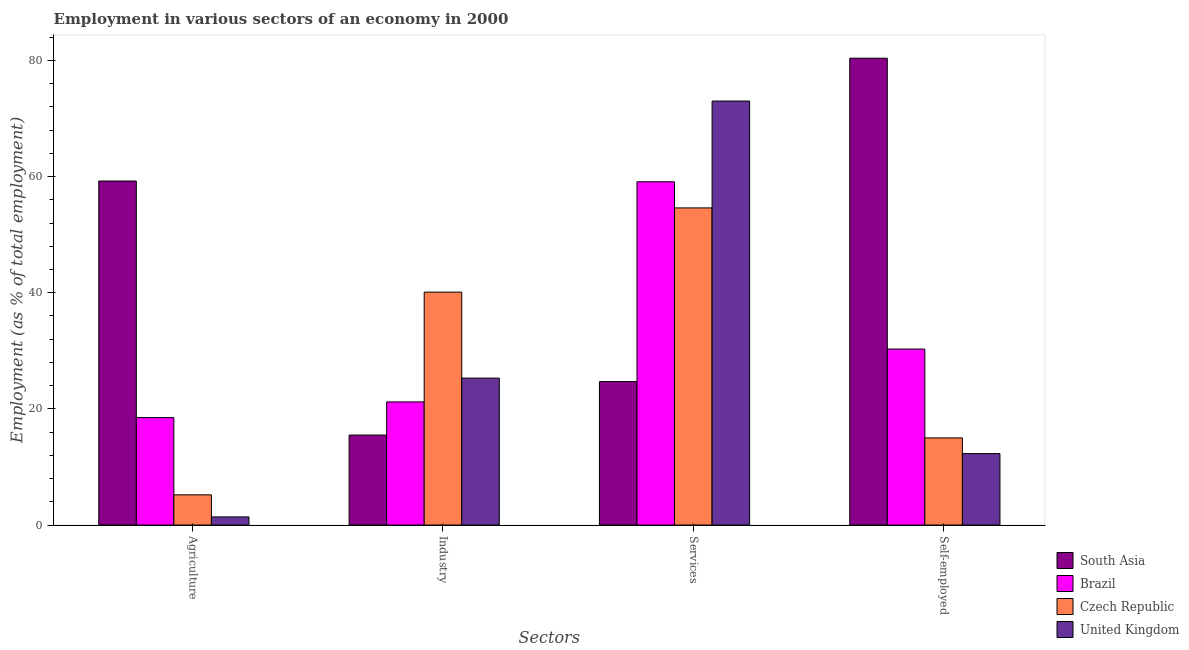How many different coloured bars are there?
Give a very brief answer. 4. Are the number of bars on each tick of the X-axis equal?
Keep it short and to the point. Yes. How many bars are there on the 3rd tick from the right?
Make the answer very short. 4. What is the label of the 1st group of bars from the left?
Give a very brief answer. Agriculture. What is the percentage of self employed workers in South Asia?
Provide a short and direct response. 80.37. Across all countries, what is the maximum percentage of self employed workers?
Give a very brief answer. 80.37. Across all countries, what is the minimum percentage of self employed workers?
Provide a succinct answer. 12.3. What is the total percentage of self employed workers in the graph?
Offer a very short reply. 137.97. What is the difference between the percentage of workers in agriculture in South Asia and that in Brazil?
Your answer should be very brief. 40.73. What is the difference between the percentage of self employed workers in Czech Republic and the percentage of workers in services in South Asia?
Provide a short and direct response. -9.7. What is the average percentage of workers in services per country?
Make the answer very short. 52.85. What is the difference between the percentage of workers in industry and percentage of workers in agriculture in United Kingdom?
Ensure brevity in your answer.  23.9. What is the ratio of the percentage of self employed workers in Czech Republic to that in Brazil?
Your answer should be very brief. 0.5. Is the percentage of self employed workers in Czech Republic less than that in Brazil?
Ensure brevity in your answer.  Yes. What is the difference between the highest and the second highest percentage of self employed workers?
Give a very brief answer. 50.07. What is the difference between the highest and the lowest percentage of workers in services?
Make the answer very short. 48.3. In how many countries, is the percentage of workers in industry greater than the average percentage of workers in industry taken over all countries?
Your answer should be compact. 1. Is the sum of the percentage of workers in industry in Brazil and Czech Republic greater than the maximum percentage of workers in agriculture across all countries?
Provide a succinct answer. Yes. What does the 1st bar from the left in Self-employed represents?
Make the answer very short. South Asia. What does the 4th bar from the right in Self-employed represents?
Ensure brevity in your answer.  South Asia. Is it the case that in every country, the sum of the percentage of workers in agriculture and percentage of workers in industry is greater than the percentage of workers in services?
Make the answer very short. No. How many bars are there?
Your response must be concise. 16. How many countries are there in the graph?
Offer a terse response. 4. What is the difference between two consecutive major ticks on the Y-axis?
Your answer should be very brief. 20. Does the graph contain any zero values?
Provide a short and direct response. No. Where does the legend appear in the graph?
Give a very brief answer. Bottom right. What is the title of the graph?
Offer a very short reply. Employment in various sectors of an economy in 2000. Does "Latin America(all income levels)" appear as one of the legend labels in the graph?
Offer a very short reply. No. What is the label or title of the X-axis?
Your response must be concise. Sectors. What is the label or title of the Y-axis?
Provide a succinct answer. Employment (as % of total employment). What is the Employment (as % of total employment) of South Asia in Agriculture?
Your answer should be very brief. 59.23. What is the Employment (as % of total employment) of Brazil in Agriculture?
Ensure brevity in your answer.  18.5. What is the Employment (as % of total employment) of Czech Republic in Agriculture?
Offer a terse response. 5.2. What is the Employment (as % of total employment) in United Kingdom in Agriculture?
Offer a very short reply. 1.4. What is the Employment (as % of total employment) in South Asia in Industry?
Make the answer very short. 15.49. What is the Employment (as % of total employment) of Brazil in Industry?
Keep it short and to the point. 21.2. What is the Employment (as % of total employment) in Czech Republic in Industry?
Your response must be concise. 40.1. What is the Employment (as % of total employment) in United Kingdom in Industry?
Offer a very short reply. 25.3. What is the Employment (as % of total employment) of South Asia in Services?
Your response must be concise. 24.7. What is the Employment (as % of total employment) in Brazil in Services?
Give a very brief answer. 59.1. What is the Employment (as % of total employment) of Czech Republic in Services?
Your response must be concise. 54.6. What is the Employment (as % of total employment) in United Kingdom in Services?
Provide a short and direct response. 73. What is the Employment (as % of total employment) in South Asia in Self-employed?
Your answer should be compact. 80.37. What is the Employment (as % of total employment) in Brazil in Self-employed?
Make the answer very short. 30.3. What is the Employment (as % of total employment) in United Kingdom in Self-employed?
Provide a short and direct response. 12.3. Across all Sectors, what is the maximum Employment (as % of total employment) of South Asia?
Your response must be concise. 80.37. Across all Sectors, what is the maximum Employment (as % of total employment) in Brazil?
Make the answer very short. 59.1. Across all Sectors, what is the maximum Employment (as % of total employment) of Czech Republic?
Your answer should be very brief. 54.6. Across all Sectors, what is the minimum Employment (as % of total employment) in South Asia?
Your answer should be very brief. 15.49. Across all Sectors, what is the minimum Employment (as % of total employment) of Czech Republic?
Give a very brief answer. 5.2. Across all Sectors, what is the minimum Employment (as % of total employment) in United Kingdom?
Make the answer very short. 1.4. What is the total Employment (as % of total employment) of South Asia in the graph?
Make the answer very short. 179.8. What is the total Employment (as % of total employment) in Brazil in the graph?
Your response must be concise. 129.1. What is the total Employment (as % of total employment) of Czech Republic in the graph?
Your answer should be compact. 114.9. What is the total Employment (as % of total employment) in United Kingdom in the graph?
Offer a very short reply. 112. What is the difference between the Employment (as % of total employment) in South Asia in Agriculture and that in Industry?
Offer a terse response. 43.74. What is the difference between the Employment (as % of total employment) in Brazil in Agriculture and that in Industry?
Your answer should be very brief. -2.7. What is the difference between the Employment (as % of total employment) in Czech Republic in Agriculture and that in Industry?
Provide a succinct answer. -34.9. What is the difference between the Employment (as % of total employment) of United Kingdom in Agriculture and that in Industry?
Provide a succinct answer. -23.9. What is the difference between the Employment (as % of total employment) in South Asia in Agriculture and that in Services?
Ensure brevity in your answer.  34.53. What is the difference between the Employment (as % of total employment) in Brazil in Agriculture and that in Services?
Make the answer very short. -40.6. What is the difference between the Employment (as % of total employment) in Czech Republic in Agriculture and that in Services?
Offer a very short reply. -49.4. What is the difference between the Employment (as % of total employment) in United Kingdom in Agriculture and that in Services?
Provide a short and direct response. -71.6. What is the difference between the Employment (as % of total employment) in South Asia in Agriculture and that in Self-employed?
Offer a very short reply. -21.14. What is the difference between the Employment (as % of total employment) in Brazil in Agriculture and that in Self-employed?
Provide a short and direct response. -11.8. What is the difference between the Employment (as % of total employment) of Czech Republic in Agriculture and that in Self-employed?
Ensure brevity in your answer.  -9.8. What is the difference between the Employment (as % of total employment) in United Kingdom in Agriculture and that in Self-employed?
Keep it short and to the point. -10.9. What is the difference between the Employment (as % of total employment) in South Asia in Industry and that in Services?
Provide a short and direct response. -9.21. What is the difference between the Employment (as % of total employment) of Brazil in Industry and that in Services?
Give a very brief answer. -37.9. What is the difference between the Employment (as % of total employment) of Czech Republic in Industry and that in Services?
Give a very brief answer. -14.5. What is the difference between the Employment (as % of total employment) in United Kingdom in Industry and that in Services?
Make the answer very short. -47.7. What is the difference between the Employment (as % of total employment) in South Asia in Industry and that in Self-employed?
Ensure brevity in your answer.  -64.88. What is the difference between the Employment (as % of total employment) of Brazil in Industry and that in Self-employed?
Offer a very short reply. -9.1. What is the difference between the Employment (as % of total employment) in Czech Republic in Industry and that in Self-employed?
Provide a succinct answer. 25.1. What is the difference between the Employment (as % of total employment) of United Kingdom in Industry and that in Self-employed?
Provide a succinct answer. 13. What is the difference between the Employment (as % of total employment) in South Asia in Services and that in Self-employed?
Keep it short and to the point. -55.67. What is the difference between the Employment (as % of total employment) of Brazil in Services and that in Self-employed?
Provide a short and direct response. 28.8. What is the difference between the Employment (as % of total employment) in Czech Republic in Services and that in Self-employed?
Provide a succinct answer. 39.6. What is the difference between the Employment (as % of total employment) of United Kingdom in Services and that in Self-employed?
Your response must be concise. 60.7. What is the difference between the Employment (as % of total employment) of South Asia in Agriculture and the Employment (as % of total employment) of Brazil in Industry?
Keep it short and to the point. 38.03. What is the difference between the Employment (as % of total employment) in South Asia in Agriculture and the Employment (as % of total employment) in Czech Republic in Industry?
Your answer should be very brief. 19.13. What is the difference between the Employment (as % of total employment) of South Asia in Agriculture and the Employment (as % of total employment) of United Kingdom in Industry?
Give a very brief answer. 33.93. What is the difference between the Employment (as % of total employment) of Brazil in Agriculture and the Employment (as % of total employment) of Czech Republic in Industry?
Ensure brevity in your answer.  -21.6. What is the difference between the Employment (as % of total employment) of Brazil in Agriculture and the Employment (as % of total employment) of United Kingdom in Industry?
Offer a terse response. -6.8. What is the difference between the Employment (as % of total employment) in Czech Republic in Agriculture and the Employment (as % of total employment) in United Kingdom in Industry?
Offer a very short reply. -20.1. What is the difference between the Employment (as % of total employment) of South Asia in Agriculture and the Employment (as % of total employment) of Brazil in Services?
Your answer should be very brief. 0.13. What is the difference between the Employment (as % of total employment) in South Asia in Agriculture and the Employment (as % of total employment) in Czech Republic in Services?
Your response must be concise. 4.63. What is the difference between the Employment (as % of total employment) of South Asia in Agriculture and the Employment (as % of total employment) of United Kingdom in Services?
Provide a short and direct response. -13.77. What is the difference between the Employment (as % of total employment) in Brazil in Agriculture and the Employment (as % of total employment) in Czech Republic in Services?
Your answer should be compact. -36.1. What is the difference between the Employment (as % of total employment) of Brazil in Agriculture and the Employment (as % of total employment) of United Kingdom in Services?
Ensure brevity in your answer.  -54.5. What is the difference between the Employment (as % of total employment) of Czech Republic in Agriculture and the Employment (as % of total employment) of United Kingdom in Services?
Ensure brevity in your answer.  -67.8. What is the difference between the Employment (as % of total employment) in South Asia in Agriculture and the Employment (as % of total employment) in Brazil in Self-employed?
Provide a short and direct response. 28.93. What is the difference between the Employment (as % of total employment) in South Asia in Agriculture and the Employment (as % of total employment) in Czech Republic in Self-employed?
Ensure brevity in your answer.  44.23. What is the difference between the Employment (as % of total employment) of South Asia in Agriculture and the Employment (as % of total employment) of United Kingdom in Self-employed?
Offer a terse response. 46.93. What is the difference between the Employment (as % of total employment) in Brazil in Agriculture and the Employment (as % of total employment) in Czech Republic in Self-employed?
Provide a short and direct response. 3.5. What is the difference between the Employment (as % of total employment) of Brazil in Agriculture and the Employment (as % of total employment) of United Kingdom in Self-employed?
Your answer should be compact. 6.2. What is the difference between the Employment (as % of total employment) of Czech Republic in Agriculture and the Employment (as % of total employment) of United Kingdom in Self-employed?
Make the answer very short. -7.1. What is the difference between the Employment (as % of total employment) of South Asia in Industry and the Employment (as % of total employment) of Brazil in Services?
Keep it short and to the point. -43.61. What is the difference between the Employment (as % of total employment) in South Asia in Industry and the Employment (as % of total employment) in Czech Republic in Services?
Ensure brevity in your answer.  -39.11. What is the difference between the Employment (as % of total employment) of South Asia in Industry and the Employment (as % of total employment) of United Kingdom in Services?
Offer a terse response. -57.51. What is the difference between the Employment (as % of total employment) of Brazil in Industry and the Employment (as % of total employment) of Czech Republic in Services?
Give a very brief answer. -33.4. What is the difference between the Employment (as % of total employment) of Brazil in Industry and the Employment (as % of total employment) of United Kingdom in Services?
Your response must be concise. -51.8. What is the difference between the Employment (as % of total employment) of Czech Republic in Industry and the Employment (as % of total employment) of United Kingdom in Services?
Your answer should be very brief. -32.9. What is the difference between the Employment (as % of total employment) of South Asia in Industry and the Employment (as % of total employment) of Brazil in Self-employed?
Make the answer very short. -14.81. What is the difference between the Employment (as % of total employment) of South Asia in Industry and the Employment (as % of total employment) of Czech Republic in Self-employed?
Keep it short and to the point. 0.49. What is the difference between the Employment (as % of total employment) of South Asia in Industry and the Employment (as % of total employment) of United Kingdom in Self-employed?
Keep it short and to the point. 3.19. What is the difference between the Employment (as % of total employment) in Czech Republic in Industry and the Employment (as % of total employment) in United Kingdom in Self-employed?
Offer a terse response. 27.8. What is the difference between the Employment (as % of total employment) of South Asia in Services and the Employment (as % of total employment) of Brazil in Self-employed?
Provide a short and direct response. -5.6. What is the difference between the Employment (as % of total employment) in South Asia in Services and the Employment (as % of total employment) in Czech Republic in Self-employed?
Your answer should be compact. 9.7. What is the difference between the Employment (as % of total employment) of South Asia in Services and the Employment (as % of total employment) of United Kingdom in Self-employed?
Your response must be concise. 12.4. What is the difference between the Employment (as % of total employment) in Brazil in Services and the Employment (as % of total employment) in Czech Republic in Self-employed?
Offer a terse response. 44.1. What is the difference between the Employment (as % of total employment) of Brazil in Services and the Employment (as % of total employment) of United Kingdom in Self-employed?
Your response must be concise. 46.8. What is the difference between the Employment (as % of total employment) of Czech Republic in Services and the Employment (as % of total employment) of United Kingdom in Self-employed?
Provide a succinct answer. 42.3. What is the average Employment (as % of total employment) of South Asia per Sectors?
Make the answer very short. 44.95. What is the average Employment (as % of total employment) in Brazil per Sectors?
Ensure brevity in your answer.  32.27. What is the average Employment (as % of total employment) in Czech Republic per Sectors?
Your answer should be very brief. 28.73. What is the average Employment (as % of total employment) in United Kingdom per Sectors?
Provide a succinct answer. 28. What is the difference between the Employment (as % of total employment) in South Asia and Employment (as % of total employment) in Brazil in Agriculture?
Offer a terse response. 40.73. What is the difference between the Employment (as % of total employment) of South Asia and Employment (as % of total employment) of Czech Republic in Agriculture?
Provide a succinct answer. 54.03. What is the difference between the Employment (as % of total employment) in South Asia and Employment (as % of total employment) in United Kingdom in Agriculture?
Provide a short and direct response. 57.83. What is the difference between the Employment (as % of total employment) of Brazil and Employment (as % of total employment) of Czech Republic in Agriculture?
Ensure brevity in your answer.  13.3. What is the difference between the Employment (as % of total employment) of Brazil and Employment (as % of total employment) of United Kingdom in Agriculture?
Give a very brief answer. 17.1. What is the difference between the Employment (as % of total employment) of Czech Republic and Employment (as % of total employment) of United Kingdom in Agriculture?
Provide a short and direct response. 3.8. What is the difference between the Employment (as % of total employment) in South Asia and Employment (as % of total employment) in Brazil in Industry?
Your response must be concise. -5.71. What is the difference between the Employment (as % of total employment) in South Asia and Employment (as % of total employment) in Czech Republic in Industry?
Ensure brevity in your answer.  -24.61. What is the difference between the Employment (as % of total employment) in South Asia and Employment (as % of total employment) in United Kingdom in Industry?
Make the answer very short. -9.81. What is the difference between the Employment (as % of total employment) of Brazil and Employment (as % of total employment) of Czech Republic in Industry?
Your answer should be compact. -18.9. What is the difference between the Employment (as % of total employment) in Czech Republic and Employment (as % of total employment) in United Kingdom in Industry?
Your answer should be compact. 14.8. What is the difference between the Employment (as % of total employment) of South Asia and Employment (as % of total employment) of Brazil in Services?
Offer a very short reply. -34.4. What is the difference between the Employment (as % of total employment) in South Asia and Employment (as % of total employment) in Czech Republic in Services?
Make the answer very short. -29.9. What is the difference between the Employment (as % of total employment) in South Asia and Employment (as % of total employment) in United Kingdom in Services?
Offer a terse response. -48.3. What is the difference between the Employment (as % of total employment) of Brazil and Employment (as % of total employment) of United Kingdom in Services?
Your answer should be compact. -13.9. What is the difference between the Employment (as % of total employment) of Czech Republic and Employment (as % of total employment) of United Kingdom in Services?
Your answer should be very brief. -18.4. What is the difference between the Employment (as % of total employment) of South Asia and Employment (as % of total employment) of Brazil in Self-employed?
Provide a succinct answer. 50.07. What is the difference between the Employment (as % of total employment) in South Asia and Employment (as % of total employment) in Czech Republic in Self-employed?
Provide a succinct answer. 65.37. What is the difference between the Employment (as % of total employment) in South Asia and Employment (as % of total employment) in United Kingdom in Self-employed?
Give a very brief answer. 68.07. What is the difference between the Employment (as % of total employment) of Brazil and Employment (as % of total employment) of Czech Republic in Self-employed?
Your answer should be compact. 15.3. What is the difference between the Employment (as % of total employment) of Brazil and Employment (as % of total employment) of United Kingdom in Self-employed?
Your response must be concise. 18. What is the ratio of the Employment (as % of total employment) of South Asia in Agriculture to that in Industry?
Provide a succinct answer. 3.82. What is the ratio of the Employment (as % of total employment) of Brazil in Agriculture to that in Industry?
Make the answer very short. 0.87. What is the ratio of the Employment (as % of total employment) of Czech Republic in Agriculture to that in Industry?
Ensure brevity in your answer.  0.13. What is the ratio of the Employment (as % of total employment) in United Kingdom in Agriculture to that in Industry?
Your answer should be very brief. 0.06. What is the ratio of the Employment (as % of total employment) of South Asia in Agriculture to that in Services?
Offer a very short reply. 2.4. What is the ratio of the Employment (as % of total employment) of Brazil in Agriculture to that in Services?
Your answer should be very brief. 0.31. What is the ratio of the Employment (as % of total employment) of Czech Republic in Agriculture to that in Services?
Keep it short and to the point. 0.1. What is the ratio of the Employment (as % of total employment) of United Kingdom in Agriculture to that in Services?
Your answer should be very brief. 0.02. What is the ratio of the Employment (as % of total employment) in South Asia in Agriculture to that in Self-employed?
Offer a very short reply. 0.74. What is the ratio of the Employment (as % of total employment) of Brazil in Agriculture to that in Self-employed?
Keep it short and to the point. 0.61. What is the ratio of the Employment (as % of total employment) of Czech Republic in Agriculture to that in Self-employed?
Offer a very short reply. 0.35. What is the ratio of the Employment (as % of total employment) in United Kingdom in Agriculture to that in Self-employed?
Keep it short and to the point. 0.11. What is the ratio of the Employment (as % of total employment) in South Asia in Industry to that in Services?
Provide a short and direct response. 0.63. What is the ratio of the Employment (as % of total employment) in Brazil in Industry to that in Services?
Provide a short and direct response. 0.36. What is the ratio of the Employment (as % of total employment) of Czech Republic in Industry to that in Services?
Your answer should be compact. 0.73. What is the ratio of the Employment (as % of total employment) in United Kingdom in Industry to that in Services?
Your response must be concise. 0.35. What is the ratio of the Employment (as % of total employment) in South Asia in Industry to that in Self-employed?
Offer a very short reply. 0.19. What is the ratio of the Employment (as % of total employment) of Brazil in Industry to that in Self-employed?
Make the answer very short. 0.7. What is the ratio of the Employment (as % of total employment) in Czech Republic in Industry to that in Self-employed?
Your response must be concise. 2.67. What is the ratio of the Employment (as % of total employment) of United Kingdom in Industry to that in Self-employed?
Give a very brief answer. 2.06. What is the ratio of the Employment (as % of total employment) of South Asia in Services to that in Self-employed?
Offer a very short reply. 0.31. What is the ratio of the Employment (as % of total employment) in Brazil in Services to that in Self-employed?
Your answer should be compact. 1.95. What is the ratio of the Employment (as % of total employment) of Czech Republic in Services to that in Self-employed?
Provide a succinct answer. 3.64. What is the ratio of the Employment (as % of total employment) in United Kingdom in Services to that in Self-employed?
Your answer should be very brief. 5.93. What is the difference between the highest and the second highest Employment (as % of total employment) of South Asia?
Provide a short and direct response. 21.14. What is the difference between the highest and the second highest Employment (as % of total employment) of Brazil?
Keep it short and to the point. 28.8. What is the difference between the highest and the second highest Employment (as % of total employment) in United Kingdom?
Provide a short and direct response. 47.7. What is the difference between the highest and the lowest Employment (as % of total employment) of South Asia?
Ensure brevity in your answer.  64.88. What is the difference between the highest and the lowest Employment (as % of total employment) in Brazil?
Give a very brief answer. 40.6. What is the difference between the highest and the lowest Employment (as % of total employment) in Czech Republic?
Offer a very short reply. 49.4. What is the difference between the highest and the lowest Employment (as % of total employment) of United Kingdom?
Provide a short and direct response. 71.6. 